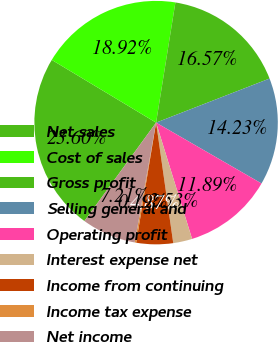<chart> <loc_0><loc_0><loc_500><loc_500><pie_chart><fcel>Net sales<fcel>Cost of sales<fcel>Gross profit<fcel>Selling general and<fcel>Operating profit<fcel>Interest expense net<fcel>Income from continuing<fcel>Income tax expense<fcel>Net income<nl><fcel>23.6%<fcel>18.92%<fcel>16.57%<fcel>14.23%<fcel>11.89%<fcel>2.53%<fcel>4.87%<fcel>0.19%<fcel>7.21%<nl></chart> 